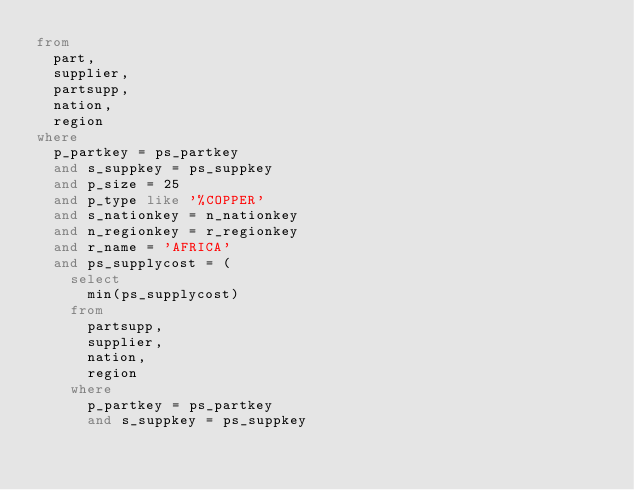<code> <loc_0><loc_0><loc_500><loc_500><_SQL_>from
	part,
	supplier,
	partsupp,
	nation,
	region
where
	p_partkey = ps_partkey
	and s_suppkey = ps_suppkey
	and p_size = 25
	and p_type like '%COPPER'
	and s_nationkey = n_nationkey
	and n_regionkey = r_regionkey
	and r_name = 'AFRICA'
	and ps_supplycost = (
		select
			min(ps_supplycost)
		from
			partsupp,
			supplier,
			nation,
			region
		where
			p_partkey = ps_partkey
			and s_suppkey = ps_suppkey</code> 